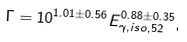Convert formula to latex. <formula><loc_0><loc_0><loc_500><loc_500>\Gamma = 1 0 ^ { 1 . 0 1 \pm 0 . 5 6 } E _ { \gamma , i s o , 5 2 } ^ { 0 . 8 8 \pm 0 . 3 5 } ,</formula> 